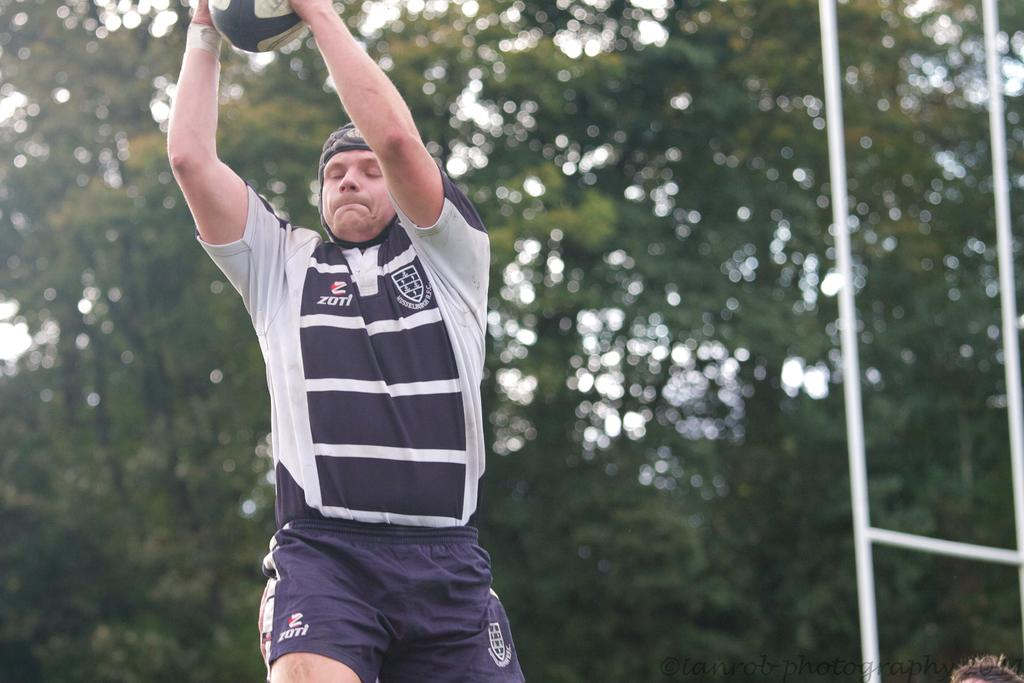Provide a one-sentence caption for the provided image. A man wears a shirt that says Zotl on one side. 